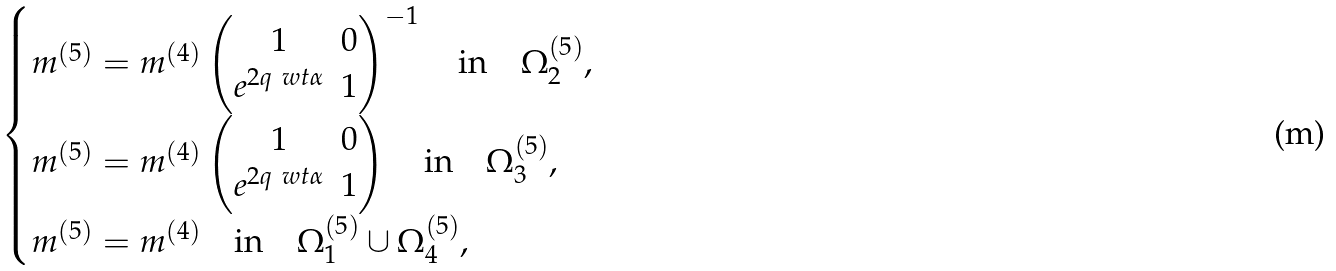Convert formula to latex. <formula><loc_0><loc_0><loc_500><loc_500>\begin{cases} m ^ { ( 5 ) } = m ^ { ( 4 ) } \begin{pmatrix} 1 & 0 \\ e ^ { 2 q \ w t { \alpha } } & 1 \end{pmatrix} ^ { - 1 } \quad \text {in} \quad \Omega ^ { ( 5 ) } _ { 2 } , \\ m ^ { ( 5 ) } = m ^ { ( 4 ) } \begin{pmatrix} 1 & 0 \\ e ^ { 2 q \ w t { \alpha } } & 1 \end{pmatrix} \quad \text {in} \quad \Omega ^ { ( 5 ) } _ { 3 } , \\ m ^ { ( 5 ) } = m ^ { ( 4 ) } \quad \text {in} \quad \Omega ^ { ( 5 ) } _ { 1 } \cup \Omega ^ { ( 5 ) } _ { 4 } , \end{cases}</formula> 